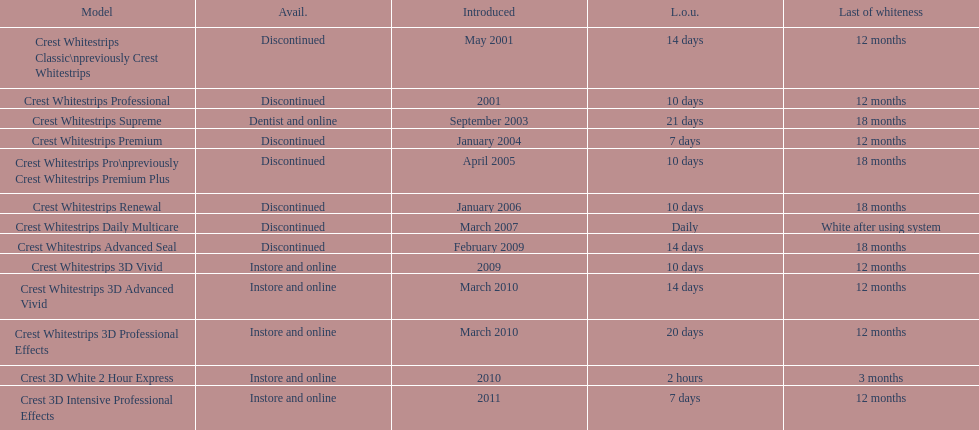Which discontinued product was introduced the same year as crest whitestrips 3d vivid? Crest Whitestrips Advanced Seal. 